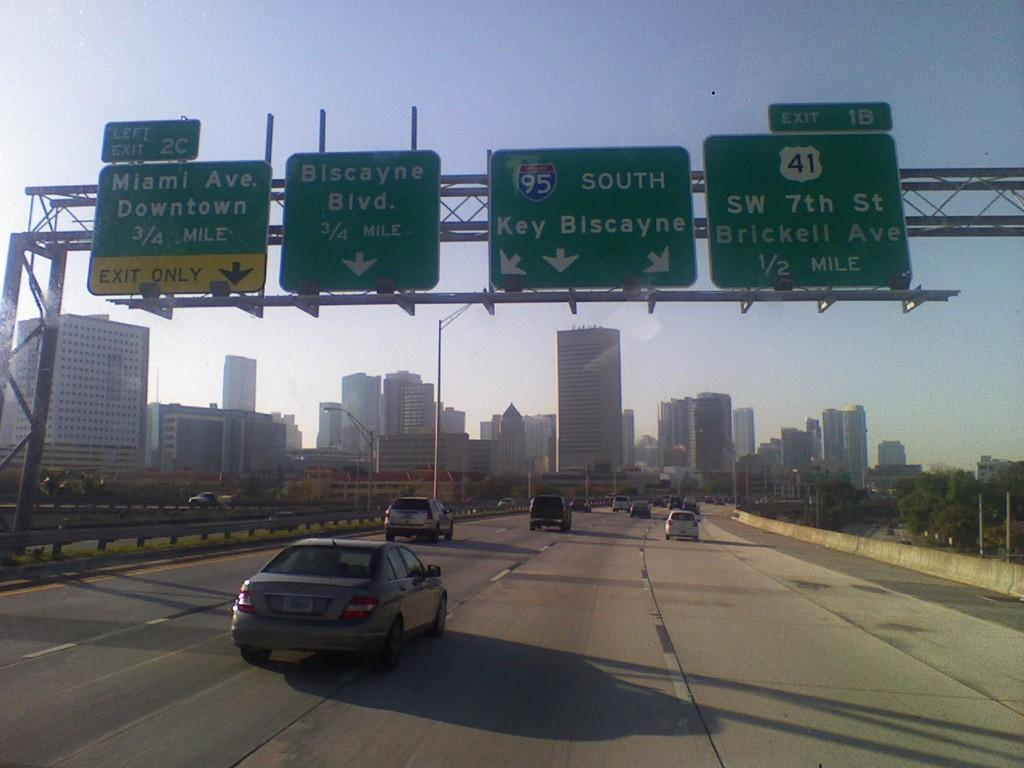What is the main feature of the image? There is a road in the image. What is happening on the road? There are cars on the road. What type of signage can be seen in the image? There are green color boards in the image. What other natural elements are present in the image? There are trees in the image. What type of man-made structures can be seen in the image? There are buildings in the image. What can be seen in the background of the image? The sky is visible in the background of the image. What type of rock is being used as a scarf by the driver of the car in the image? There is no rock or driver visible in the image; it only shows a road, cars, green color boards, trees, buildings, and the sky. 